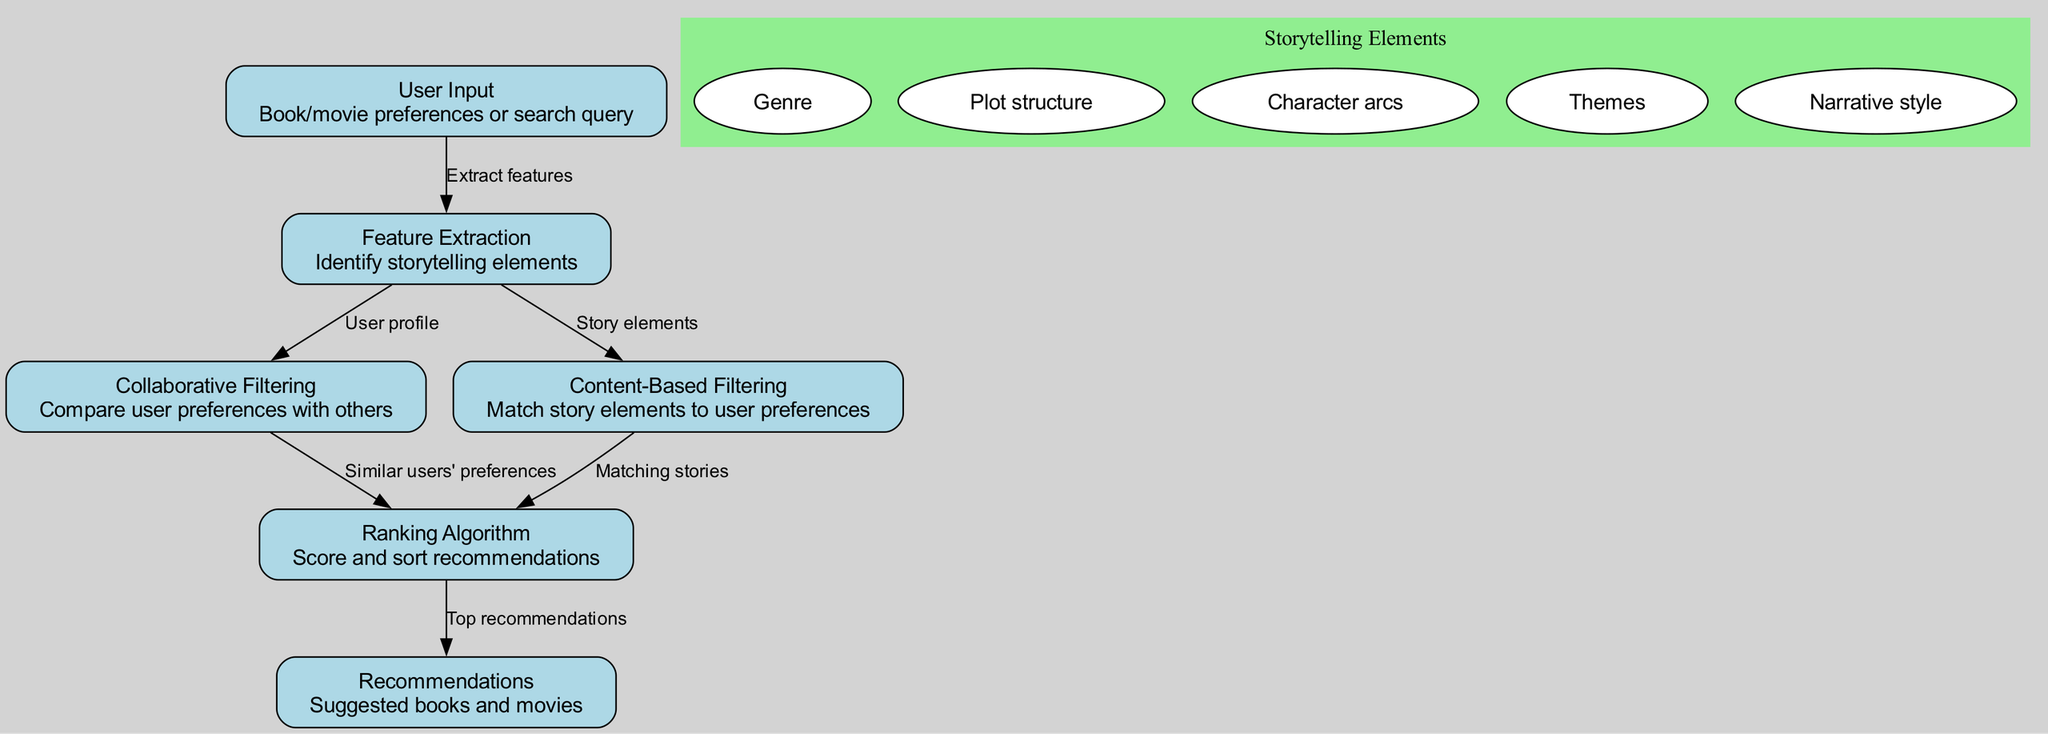What is the first node in the diagram? The first node is labeled "User Input," which indicates it is where user preferences or search queries are provided.
Answer: User Input How many edges connect to the "Ranking Algorithm" node? The "Ranking Algorithm" node has two incoming edges, one from "Collaborative Filtering" and another from "Content-Based Filtering."
Answer: 2 What is the purpose of the "Content-Based Filtering" node? The "Content-Based Filtering" node's purpose is to match story elements to user preferences, making it crucial for personalized recommendations based on the content of books and movies.
Answer: Match story elements to user preferences What storytelling elements are listed in the diagram? The elements are Genre, Plot structure, Character arcs, Themes, and Narrative style. These components are part of the feature extraction process to refine user suggestions.
Answer: Genre, Plot structure, Character arcs, Themes, Narrative style What does the "Ranking Algorithm" node produce? The "Ranking Algorithm" node produces the final output of the system, which is the top recommendations based on the previous filtering steps.
Answer: Top recommendations What is the flow from "Feature Extraction" to "Ranking Algorithm"? The flow includes the extraction of user profiles applicable for collaborative filtering and matching stories based on content-based filtering, both of which contribute to the ranking process.
Answer: User profile and matching stories How do "Collaborative Filtering" and "Content-Based Filtering" contribute to the recommendations? Both filtering methods provide different perspectives: Collaborative filtering uses similar users' preferences, while content-based filtering focuses on matching story elements to individual preferences, which both inform the ranking of recommendations.
Answer: They provide different perspectives on user preferences What connects "User Input" to "Feature Extraction"? "User Input" connects to "Feature Extraction" through the action of extracting features, which translates user preferences or queries into identifiable storytelling elements.
Answer: Extract features 